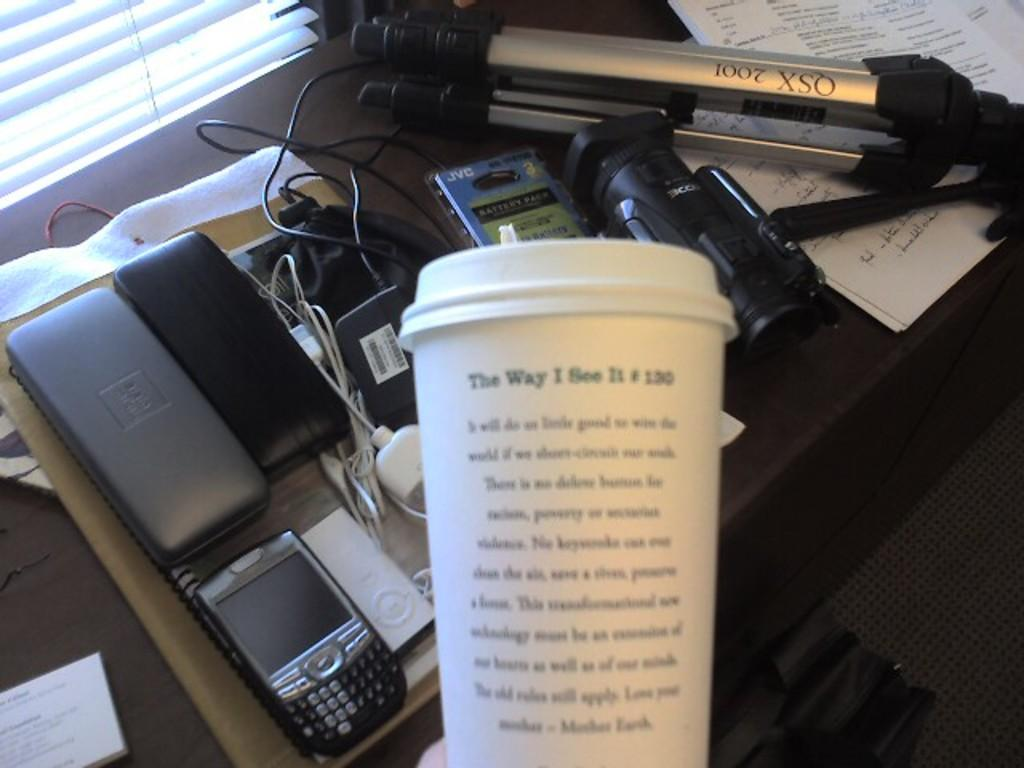<image>
Offer a succinct explanation of the picture presented. We see a workstation and the back of the coffee cup that reads The way I see it. 